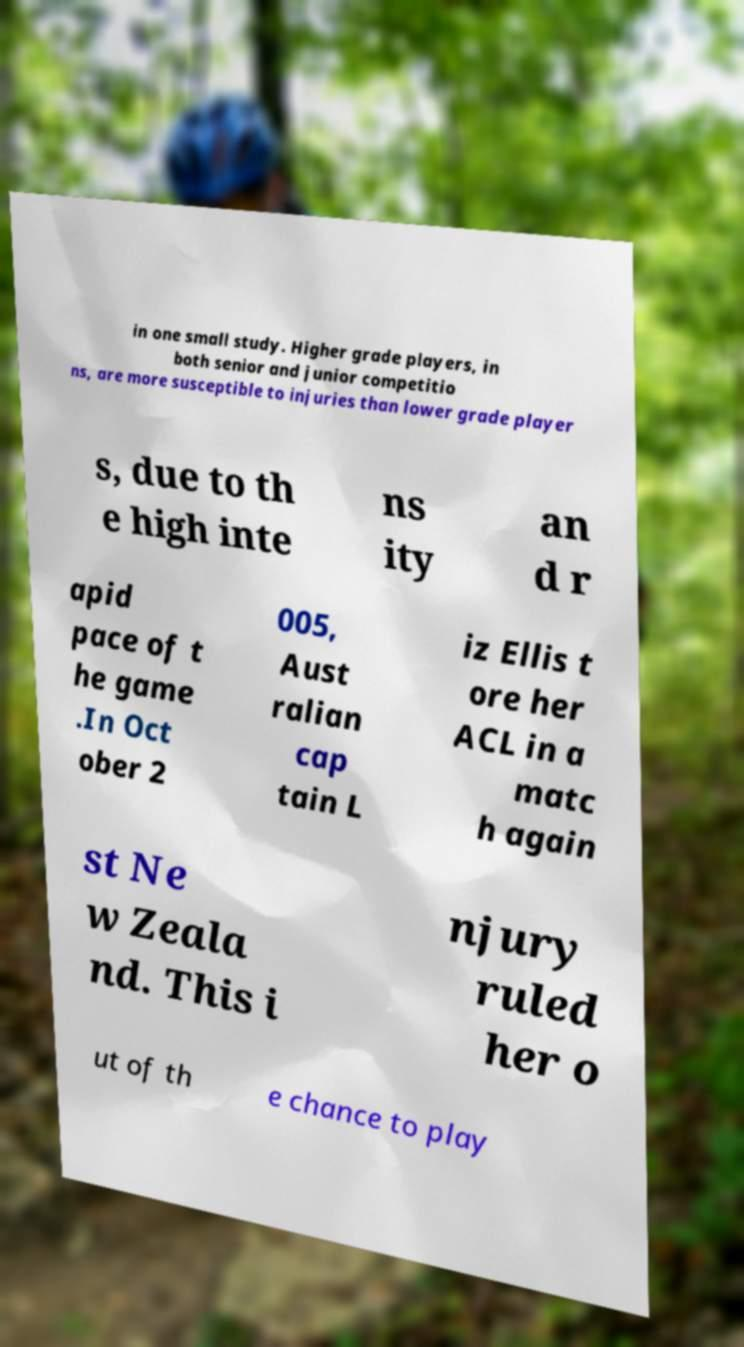What messages or text are displayed in this image? I need them in a readable, typed format. in one small study. Higher grade players, in both senior and junior competitio ns, are more susceptible to injuries than lower grade player s, due to th e high inte ns ity an d r apid pace of t he game .In Oct ober 2 005, Aust ralian cap tain L iz Ellis t ore her ACL in a matc h again st Ne w Zeala nd. This i njury ruled her o ut of th e chance to play 